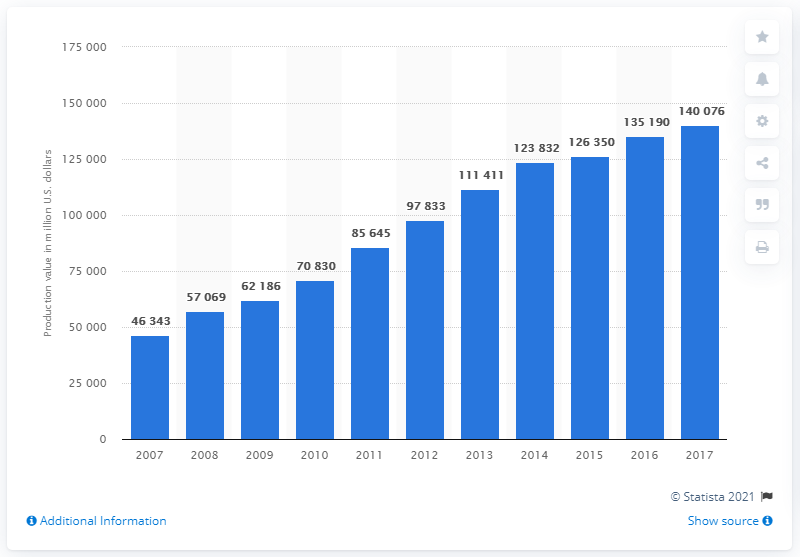Identify some key points in this picture. The production value of aquaculture in China in 2017 was approximately 140,076 U.S. dollars. 